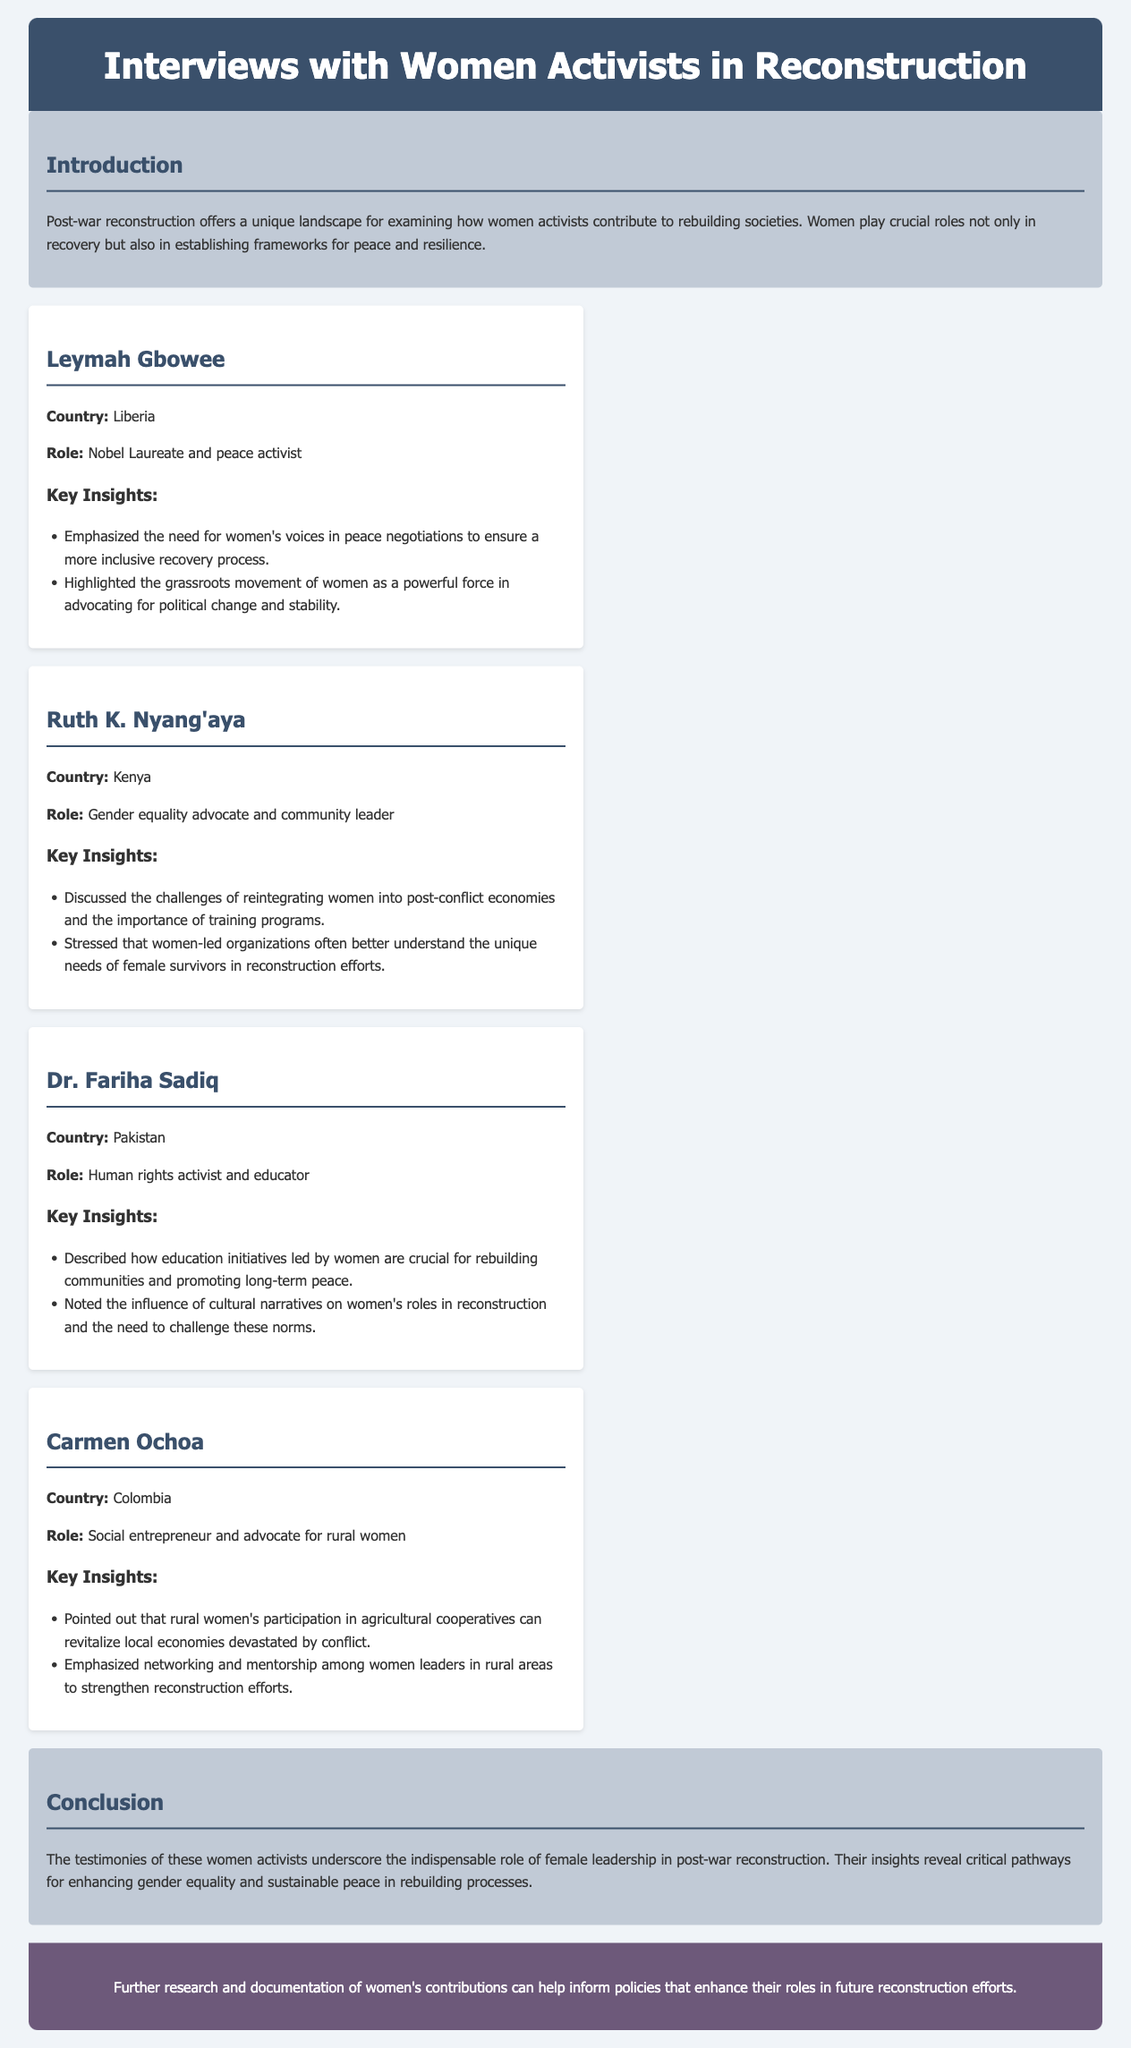What is the primary focus of the document? The primary focus is on the qualitative insights and experiences shared by female leaders in post-war reconstruction efforts.
Answer: Qualitative insights and experiences shared by female leaders in post-war reconstruction Who is a Nobel Laureate mentioned in the document? Leymah Gbowee is identified in the document as a Nobel Laureate and peace activist.
Answer: Leymah Gbowee Which country does Ruth K. Nyang'aya represent? The document specifies that Ruth K. Nyang'aya represents Kenya.
Answer: Kenya What aspect of women's roles in reconstruction did Dr. Fariha Sadiq highlight? Dr. Fariha Sadiq highlighted the importance of education initiatives led by women for rebuilding communities.
Answer: Education initiatives What is emphasized as a benefit of rural women's participation according to Carmen Ochoa? The document states that rural women's participation in agricultural cooperatives can revitalize local economies.
Answer: Revitalize local economies What common challenge faced by women in post-conflict economies was discussed? The challenges of reintegrating women into post-conflict economies and the importance of training programs were discussed.
Answer: Reintegration into post-conflict economies How does the conclusion summarize the role of female leadership? The conclusion states that women's testimonies underscore the indispensable role of female leadership in post-war reconstruction.
Answer: Indispensable role of female leadership What action does the document suggest for future policies regarding women in reconstruction? It suggests that further research and documentation can inform policies enhancing women's roles in reconstruction efforts.
Answer: Further research and documentation 